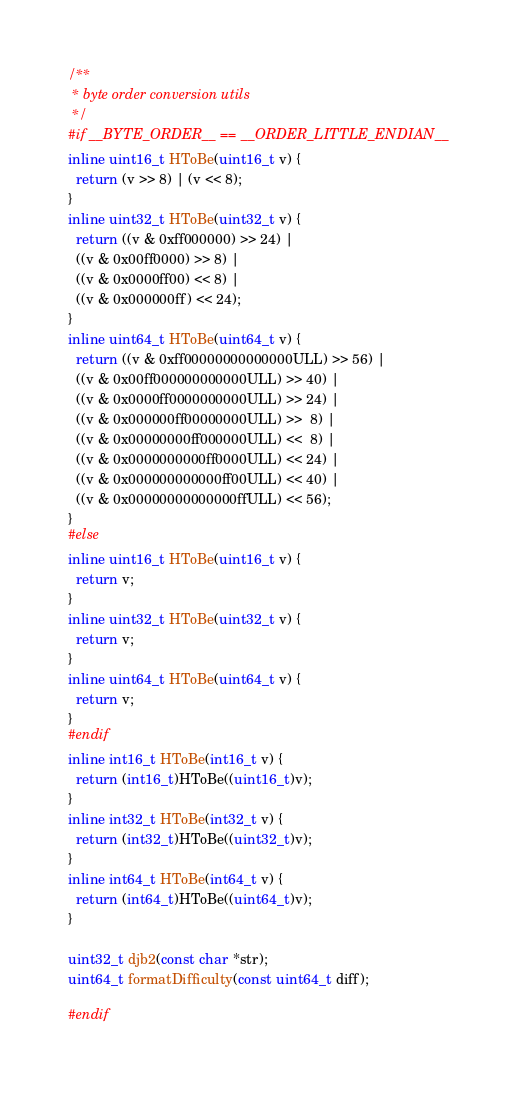Convert code to text. <code><loc_0><loc_0><loc_500><loc_500><_C_>
/**
 * byte order conversion utils
 */
#if __BYTE_ORDER__ == __ORDER_LITTLE_ENDIAN__
inline uint16_t HToBe(uint16_t v) {
  return (v >> 8) | (v << 8);
}
inline uint32_t HToBe(uint32_t v) {
  return ((v & 0xff000000) >> 24) |
  ((v & 0x00ff0000) >> 8) |
  ((v & 0x0000ff00) << 8) |
  ((v & 0x000000ff) << 24);
}
inline uint64_t HToBe(uint64_t v) {
  return ((v & 0xff00000000000000ULL) >> 56) |
  ((v & 0x00ff000000000000ULL) >> 40) |
  ((v & 0x0000ff0000000000ULL) >> 24) |
  ((v & 0x000000ff00000000ULL) >>  8) |
  ((v & 0x00000000ff000000ULL) <<  8) |
  ((v & 0x0000000000ff0000ULL) << 24) |
  ((v & 0x000000000000ff00ULL) << 40) |
  ((v & 0x00000000000000ffULL) << 56);
}
#else
inline uint16_t HToBe(uint16_t v) {
  return v;
}
inline uint32_t HToBe(uint32_t v) {
  return v;
}
inline uint64_t HToBe(uint64_t v) {
  return v;
}
#endif
inline int16_t HToBe(int16_t v) {
  return (int16_t)HToBe((uint16_t)v);
}
inline int32_t HToBe(int32_t v) {
  return (int32_t)HToBe((uint32_t)v);
}
inline int64_t HToBe(int64_t v) {
  return (int64_t)HToBe((uint64_t)v);
}

uint32_t djb2(const char *str);
uint64_t formatDifficulty(const uint64_t diff);

#endif
</code> 